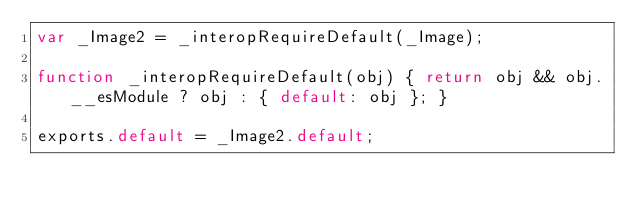Convert code to text. <code><loc_0><loc_0><loc_500><loc_500><_JavaScript_>var _Image2 = _interopRequireDefault(_Image);

function _interopRequireDefault(obj) { return obj && obj.__esModule ? obj : { default: obj }; }

exports.default = _Image2.default;</code> 